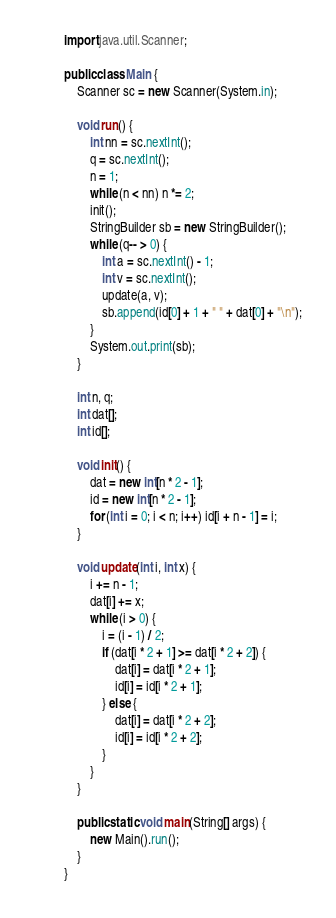<code> <loc_0><loc_0><loc_500><loc_500><_Java_>import java.util.Scanner;

public class Main {
	Scanner sc = new Scanner(System.in);

	void run() {
		int nn = sc.nextInt();
		q = sc.nextInt();
		n = 1;
		while (n < nn) n *= 2;
		init();
		StringBuilder sb = new StringBuilder();
		while (q-- > 0) {
			int a = sc.nextInt() - 1;
			int v = sc.nextInt();
			update(a, v);
			sb.append(id[0] + 1 + " " + dat[0] + "\n");
		}
		System.out.print(sb);
	}

	int n, q;
	int dat[];
	int id[];

	void init() {
		dat = new int[n * 2 - 1];
		id = new int[n * 2 - 1];
		for (int i = 0; i < n; i++) id[i + n - 1] = i;
	}

	void update(int i, int x) {
		i += n - 1;
		dat[i] += x;
		while (i > 0) {
			i = (i - 1) / 2;
			if (dat[i * 2 + 1] >= dat[i * 2 + 2]) {
				dat[i] = dat[i * 2 + 1];
				id[i] = id[i * 2 + 1];
			} else {
				dat[i] = dat[i * 2 + 2];
				id[i] = id[i * 2 + 2];
			}
		}
	}

	public static void main(String[] args) {
		new Main().run();
	}
}</code> 